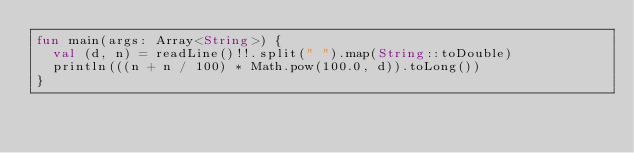Convert code to text. <code><loc_0><loc_0><loc_500><loc_500><_Kotlin_>fun main(args: Array<String>) {
  val (d, n) = readLine()!!.split(" ").map(String::toDouble)
  println(((n + n / 100) * Math.pow(100.0, d)).toLong())
}</code> 